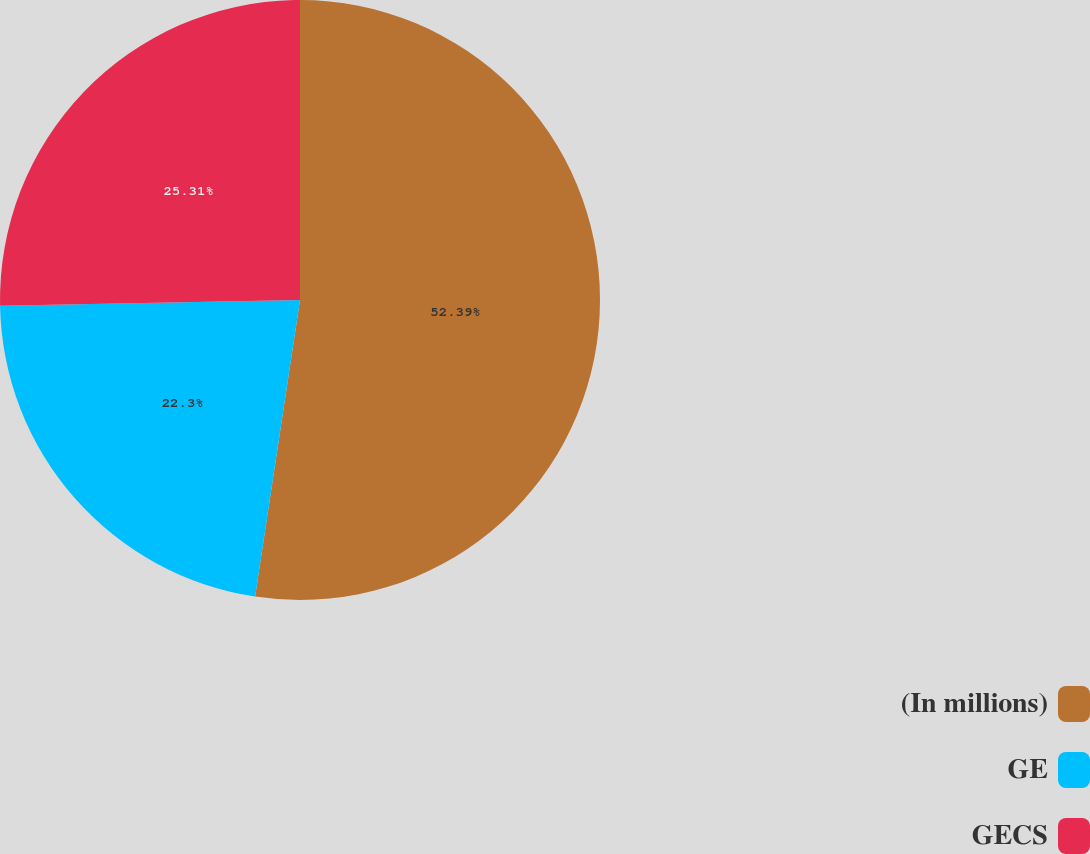Convert chart to OTSL. <chart><loc_0><loc_0><loc_500><loc_500><pie_chart><fcel>(In millions)<fcel>GE<fcel>GECS<nl><fcel>52.39%<fcel>22.3%<fcel>25.31%<nl></chart> 